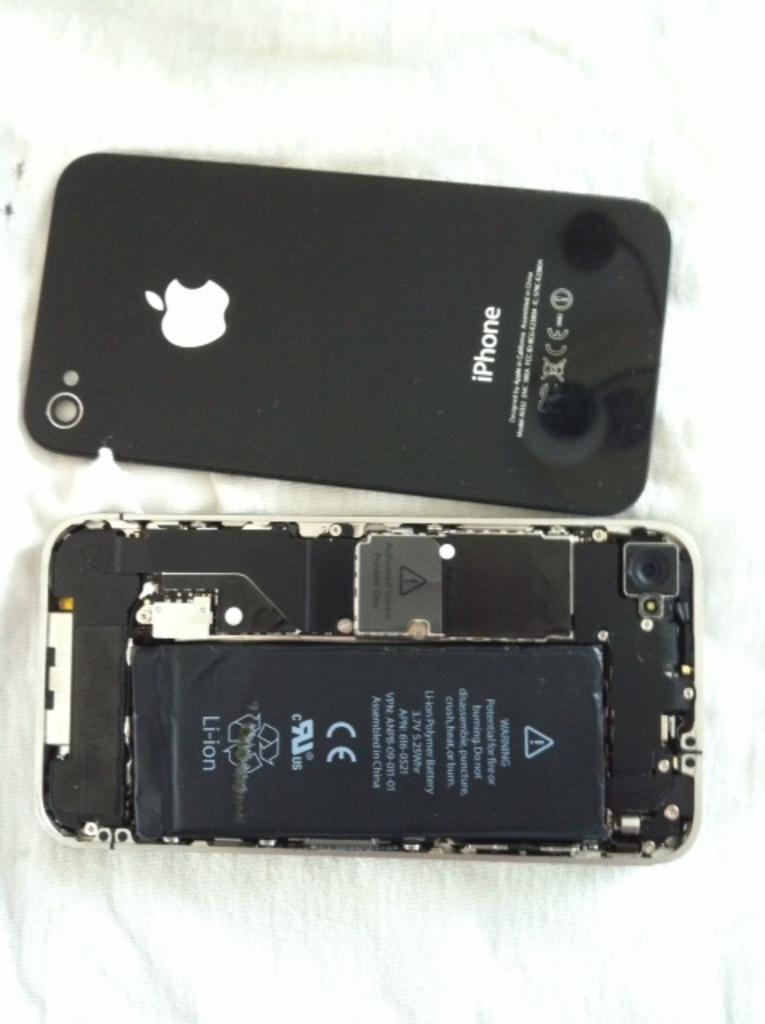<image>
Write a terse but informative summary of the picture. An iPhone is shown with and without the back cover removed to show the lithium ion battery. 